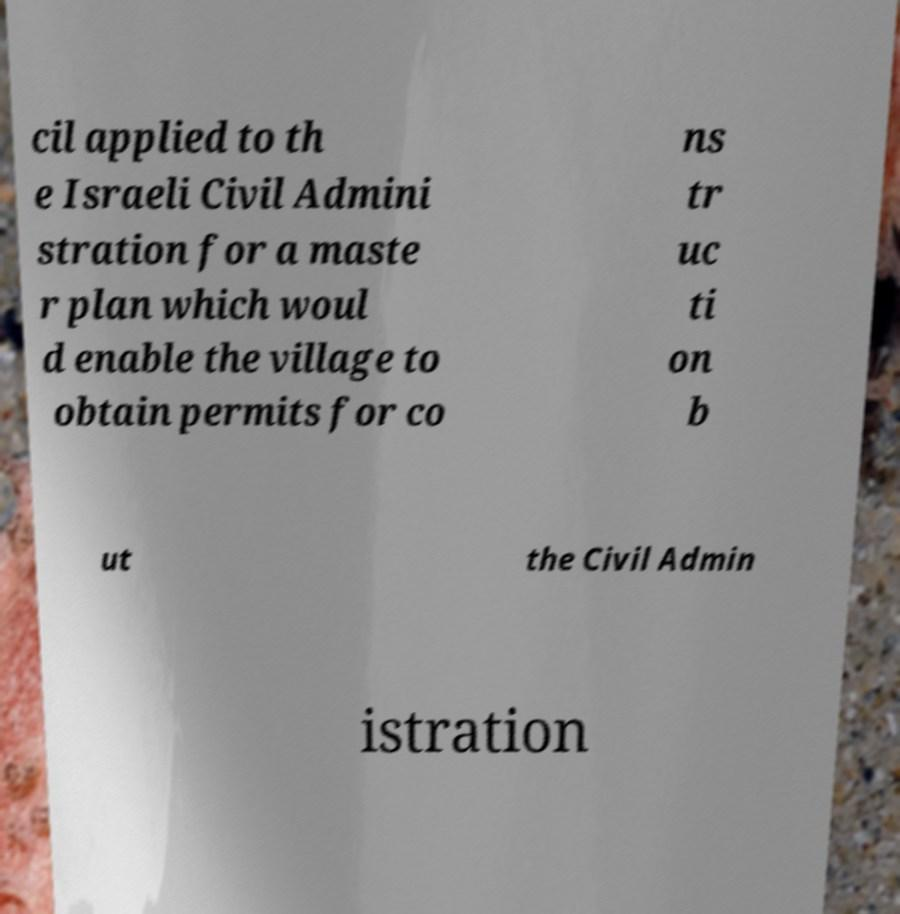Please read and relay the text visible in this image. What does it say? cil applied to th e Israeli Civil Admini stration for a maste r plan which woul d enable the village to obtain permits for co ns tr uc ti on b ut the Civil Admin istration 